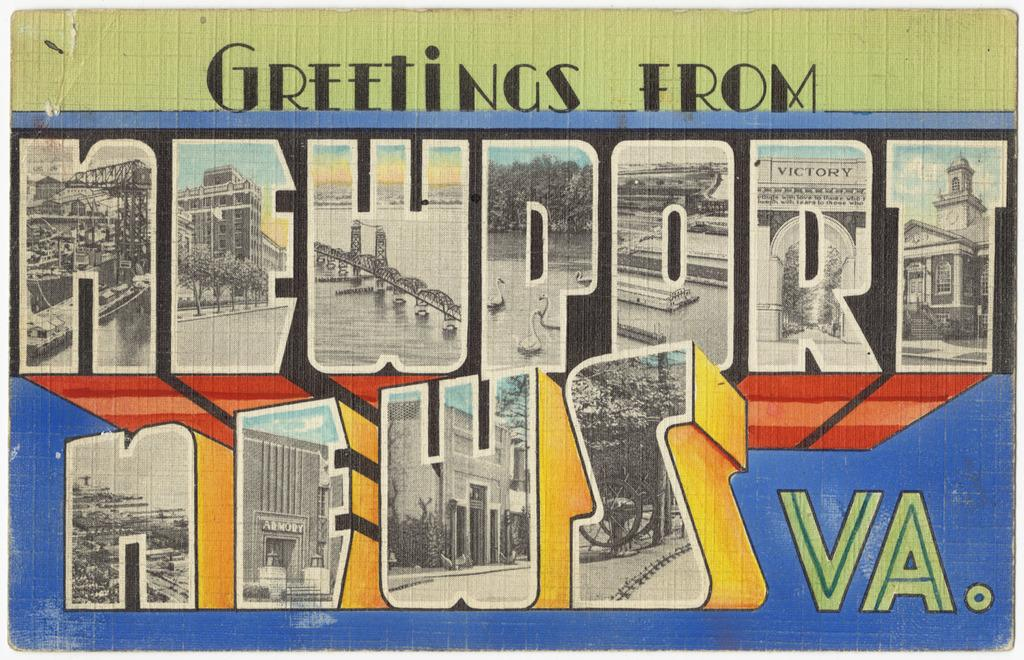Provide a one-sentence caption for the provided image. A postcard that reads Greetings from Newport News VA. 